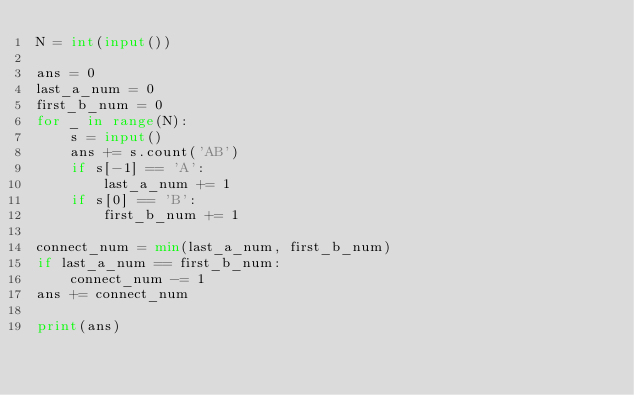<code> <loc_0><loc_0><loc_500><loc_500><_Python_>N = int(input())

ans = 0
last_a_num = 0
first_b_num = 0
for _ in range(N):
    s = input()
    ans += s.count('AB')
    if s[-1] == 'A':
        last_a_num += 1
    if s[0] == 'B':
        first_b_num += 1

connect_num = min(last_a_num, first_b_num)
if last_a_num == first_b_num:
    connect_num -= 1
ans += connect_num

print(ans)</code> 